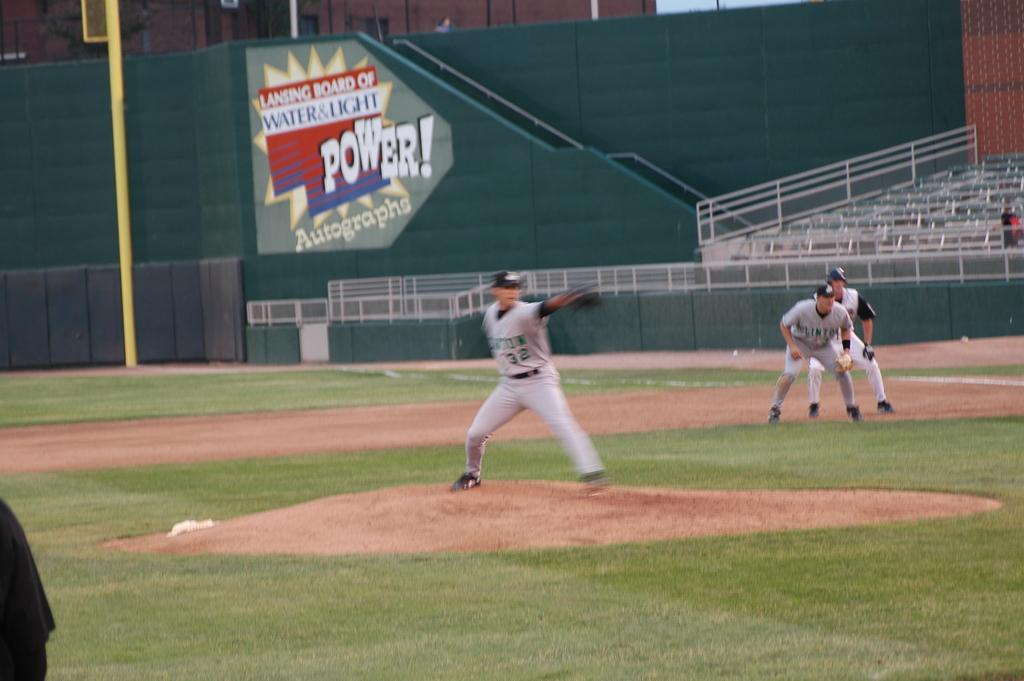<image>
Write a terse but informative summary of the picture. a sign that says power on the side 